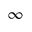Convert formula to latex. <formula><loc_0><loc_0><loc_500><loc_500>\infty</formula> 